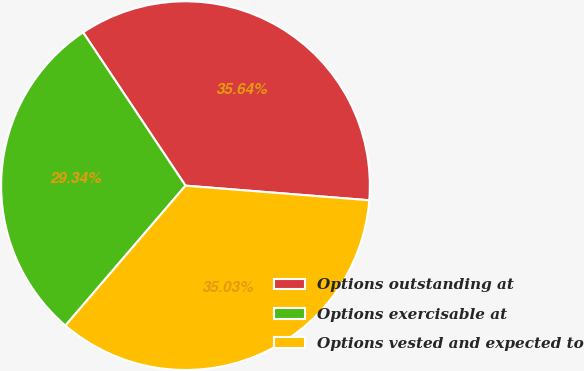Convert chart. <chart><loc_0><loc_0><loc_500><loc_500><pie_chart><fcel>Options outstanding at<fcel>Options exercisable at<fcel>Options vested and expected to<nl><fcel>35.64%<fcel>29.34%<fcel>35.03%<nl></chart> 